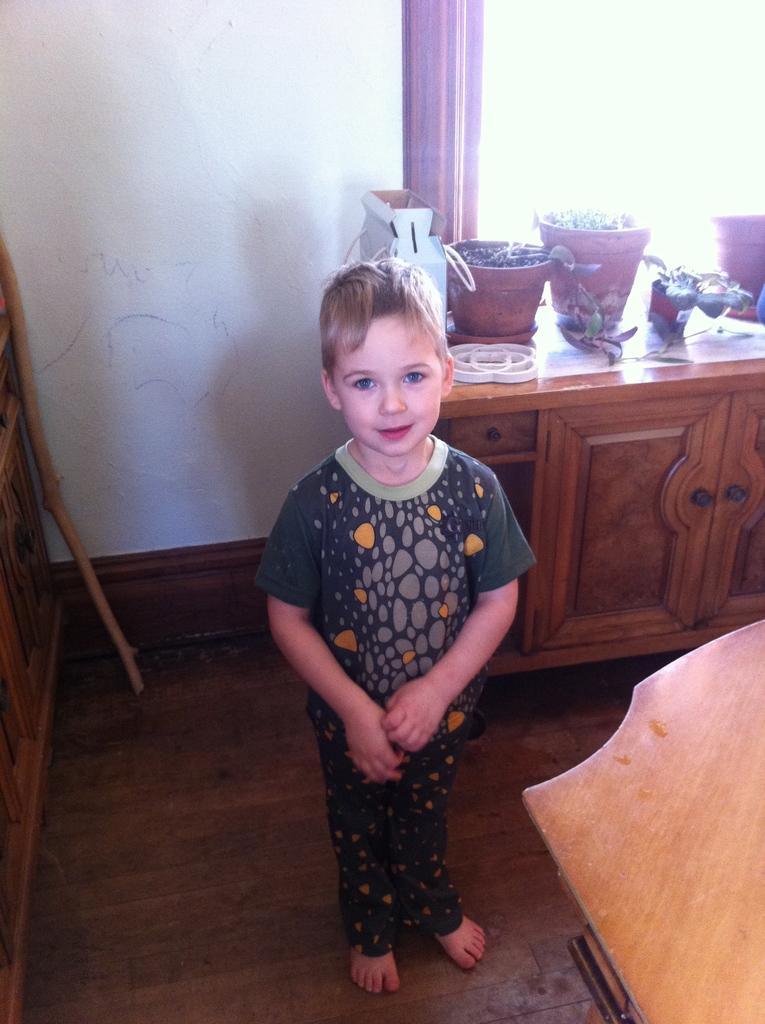What is the color of the wall in the image? The wall in the image is white. What object can be seen on the wall? There is no object visible on the wall in the image. What is located on the table in the image? There are pots on the table in the image. Who is present in the image? There is a boy standing in the image. What is the comparison between the spring season and the image? There is no reference to the spring season in the image, so it is not possible to make a comparison. 